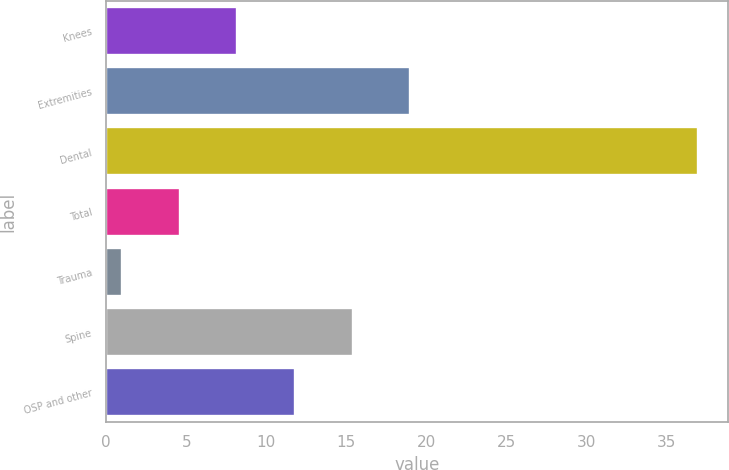<chart> <loc_0><loc_0><loc_500><loc_500><bar_chart><fcel>Knees<fcel>Extremities<fcel>Dental<fcel>Total<fcel>Trauma<fcel>Spine<fcel>OSP and other<nl><fcel>8.2<fcel>19<fcel>37<fcel>4.6<fcel>1<fcel>15.4<fcel>11.8<nl></chart> 